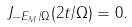Convert formula to latex. <formula><loc_0><loc_0><loc_500><loc_500>J _ { - E _ { M } / \Omega } ( 2 t / \Omega ) = 0 .</formula> 